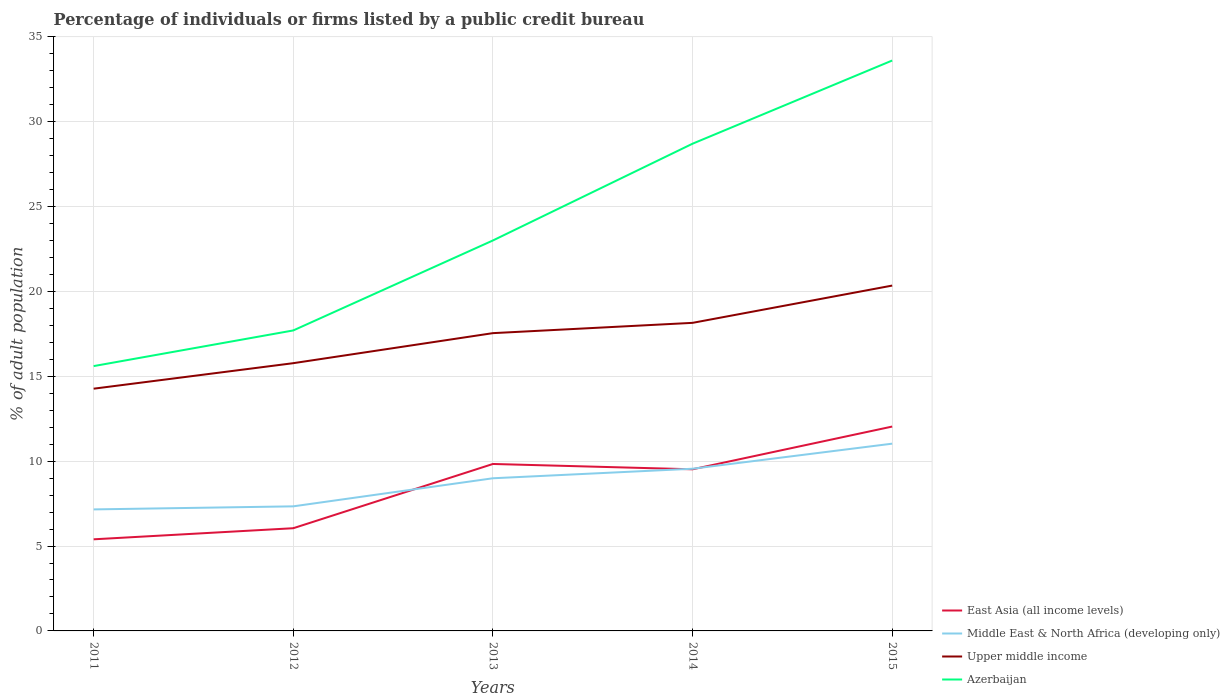Across all years, what is the maximum percentage of population listed by a public credit bureau in Middle East & North Africa (developing only)?
Ensure brevity in your answer.  7.16. What is the total percentage of population listed by a public credit bureau in Azerbaijan in the graph?
Provide a succinct answer. -4.9. What is the difference between the highest and the second highest percentage of population listed by a public credit bureau in Upper middle income?
Make the answer very short. 6.07. Is the percentage of population listed by a public credit bureau in Azerbaijan strictly greater than the percentage of population listed by a public credit bureau in Upper middle income over the years?
Your answer should be very brief. No. How many years are there in the graph?
Ensure brevity in your answer.  5. Are the values on the major ticks of Y-axis written in scientific E-notation?
Your answer should be very brief. No. Does the graph contain any zero values?
Give a very brief answer. No. Does the graph contain grids?
Your answer should be very brief. Yes. Where does the legend appear in the graph?
Offer a very short reply. Bottom right. What is the title of the graph?
Offer a terse response. Percentage of individuals or firms listed by a public credit bureau. What is the label or title of the X-axis?
Keep it short and to the point. Years. What is the label or title of the Y-axis?
Your answer should be very brief. % of adult population. What is the % of adult population in East Asia (all income levels) in 2011?
Ensure brevity in your answer.  5.4. What is the % of adult population of Middle East & North Africa (developing only) in 2011?
Offer a very short reply. 7.16. What is the % of adult population in Upper middle income in 2011?
Keep it short and to the point. 14.27. What is the % of adult population of Azerbaijan in 2011?
Offer a very short reply. 15.6. What is the % of adult population of East Asia (all income levels) in 2012?
Your answer should be very brief. 6.05. What is the % of adult population of Middle East & North Africa (developing only) in 2012?
Provide a succinct answer. 7.34. What is the % of adult population of Upper middle income in 2012?
Your response must be concise. 15.77. What is the % of adult population of Azerbaijan in 2012?
Your answer should be compact. 17.7. What is the % of adult population in East Asia (all income levels) in 2013?
Provide a succinct answer. 9.83. What is the % of adult population in Middle East & North Africa (developing only) in 2013?
Provide a short and direct response. 8.99. What is the % of adult population of Upper middle income in 2013?
Ensure brevity in your answer.  17.54. What is the % of adult population in East Asia (all income levels) in 2014?
Ensure brevity in your answer.  9.52. What is the % of adult population in Middle East & North Africa (developing only) in 2014?
Keep it short and to the point. 9.55. What is the % of adult population in Upper middle income in 2014?
Provide a short and direct response. 18.15. What is the % of adult population in Azerbaijan in 2014?
Provide a short and direct response. 28.7. What is the % of adult population of East Asia (all income levels) in 2015?
Offer a terse response. 12.04. What is the % of adult population of Middle East & North Africa (developing only) in 2015?
Provide a short and direct response. 11.03. What is the % of adult population of Upper middle income in 2015?
Your answer should be compact. 20.34. What is the % of adult population of Azerbaijan in 2015?
Provide a succinct answer. 33.6. Across all years, what is the maximum % of adult population of East Asia (all income levels)?
Give a very brief answer. 12.04. Across all years, what is the maximum % of adult population in Middle East & North Africa (developing only)?
Offer a very short reply. 11.03. Across all years, what is the maximum % of adult population in Upper middle income?
Keep it short and to the point. 20.34. Across all years, what is the maximum % of adult population of Azerbaijan?
Your answer should be very brief. 33.6. Across all years, what is the minimum % of adult population in East Asia (all income levels)?
Provide a short and direct response. 5.4. Across all years, what is the minimum % of adult population of Middle East & North Africa (developing only)?
Ensure brevity in your answer.  7.16. Across all years, what is the minimum % of adult population in Upper middle income?
Your response must be concise. 14.27. What is the total % of adult population of East Asia (all income levels) in the graph?
Your response must be concise. 42.84. What is the total % of adult population of Middle East & North Africa (developing only) in the graph?
Your response must be concise. 44.07. What is the total % of adult population in Upper middle income in the graph?
Your response must be concise. 86.07. What is the total % of adult population in Azerbaijan in the graph?
Your answer should be very brief. 118.6. What is the difference between the % of adult population of East Asia (all income levels) in 2011 and that in 2012?
Your answer should be compact. -0.65. What is the difference between the % of adult population of Middle East & North Africa (developing only) in 2011 and that in 2012?
Offer a very short reply. -0.18. What is the difference between the % of adult population in Upper middle income in 2011 and that in 2012?
Keep it short and to the point. -1.5. What is the difference between the % of adult population of East Asia (all income levels) in 2011 and that in 2013?
Make the answer very short. -4.44. What is the difference between the % of adult population in Middle East & North Africa (developing only) in 2011 and that in 2013?
Your answer should be compact. -1.83. What is the difference between the % of adult population in Upper middle income in 2011 and that in 2013?
Make the answer very short. -3.27. What is the difference between the % of adult population of Azerbaijan in 2011 and that in 2013?
Keep it short and to the point. -7.4. What is the difference between the % of adult population of East Asia (all income levels) in 2011 and that in 2014?
Provide a short and direct response. -4.12. What is the difference between the % of adult population in Middle East & North Africa (developing only) in 2011 and that in 2014?
Offer a very short reply. -2.4. What is the difference between the % of adult population in Upper middle income in 2011 and that in 2014?
Ensure brevity in your answer.  -3.88. What is the difference between the % of adult population in East Asia (all income levels) in 2011 and that in 2015?
Give a very brief answer. -6.64. What is the difference between the % of adult population of Middle East & North Africa (developing only) in 2011 and that in 2015?
Make the answer very short. -3.87. What is the difference between the % of adult population in Upper middle income in 2011 and that in 2015?
Give a very brief answer. -6.07. What is the difference between the % of adult population in East Asia (all income levels) in 2012 and that in 2013?
Provide a succinct answer. -3.78. What is the difference between the % of adult population of Middle East & North Africa (developing only) in 2012 and that in 2013?
Offer a terse response. -1.65. What is the difference between the % of adult population in Upper middle income in 2012 and that in 2013?
Provide a short and direct response. -1.77. What is the difference between the % of adult population in Azerbaijan in 2012 and that in 2013?
Provide a short and direct response. -5.3. What is the difference between the % of adult population in East Asia (all income levels) in 2012 and that in 2014?
Keep it short and to the point. -3.47. What is the difference between the % of adult population of Middle East & North Africa (developing only) in 2012 and that in 2014?
Offer a very short reply. -2.22. What is the difference between the % of adult population in Upper middle income in 2012 and that in 2014?
Keep it short and to the point. -2.38. What is the difference between the % of adult population of East Asia (all income levels) in 2012 and that in 2015?
Make the answer very short. -5.99. What is the difference between the % of adult population of Middle East & North Africa (developing only) in 2012 and that in 2015?
Offer a terse response. -3.69. What is the difference between the % of adult population in Upper middle income in 2012 and that in 2015?
Your answer should be compact. -4.57. What is the difference between the % of adult population of Azerbaijan in 2012 and that in 2015?
Offer a terse response. -15.9. What is the difference between the % of adult population of East Asia (all income levels) in 2013 and that in 2014?
Your answer should be very brief. 0.31. What is the difference between the % of adult population in Middle East & North Africa (developing only) in 2013 and that in 2014?
Your answer should be very brief. -0.56. What is the difference between the % of adult population of Upper middle income in 2013 and that in 2014?
Make the answer very short. -0.61. What is the difference between the % of adult population in Azerbaijan in 2013 and that in 2014?
Your answer should be compact. -5.7. What is the difference between the % of adult population of East Asia (all income levels) in 2013 and that in 2015?
Your answer should be very brief. -2.2. What is the difference between the % of adult population in Middle East & North Africa (developing only) in 2013 and that in 2015?
Offer a terse response. -2.04. What is the difference between the % of adult population in Upper middle income in 2013 and that in 2015?
Offer a very short reply. -2.8. What is the difference between the % of adult population of Azerbaijan in 2013 and that in 2015?
Keep it short and to the point. -10.6. What is the difference between the % of adult population of East Asia (all income levels) in 2014 and that in 2015?
Your answer should be compact. -2.52. What is the difference between the % of adult population of Middle East & North Africa (developing only) in 2014 and that in 2015?
Give a very brief answer. -1.48. What is the difference between the % of adult population in Upper middle income in 2014 and that in 2015?
Give a very brief answer. -2.2. What is the difference between the % of adult population in Azerbaijan in 2014 and that in 2015?
Provide a succinct answer. -4.9. What is the difference between the % of adult population of East Asia (all income levels) in 2011 and the % of adult population of Middle East & North Africa (developing only) in 2012?
Provide a succinct answer. -1.94. What is the difference between the % of adult population of East Asia (all income levels) in 2011 and the % of adult population of Upper middle income in 2012?
Provide a succinct answer. -10.38. What is the difference between the % of adult population of East Asia (all income levels) in 2011 and the % of adult population of Azerbaijan in 2012?
Ensure brevity in your answer.  -12.3. What is the difference between the % of adult population in Middle East & North Africa (developing only) in 2011 and the % of adult population in Upper middle income in 2012?
Your response must be concise. -8.61. What is the difference between the % of adult population in Middle East & North Africa (developing only) in 2011 and the % of adult population in Azerbaijan in 2012?
Make the answer very short. -10.54. What is the difference between the % of adult population in Upper middle income in 2011 and the % of adult population in Azerbaijan in 2012?
Offer a terse response. -3.43. What is the difference between the % of adult population in East Asia (all income levels) in 2011 and the % of adult population in Middle East & North Africa (developing only) in 2013?
Your answer should be compact. -3.6. What is the difference between the % of adult population in East Asia (all income levels) in 2011 and the % of adult population in Upper middle income in 2013?
Ensure brevity in your answer.  -12.14. What is the difference between the % of adult population in East Asia (all income levels) in 2011 and the % of adult population in Azerbaijan in 2013?
Your answer should be compact. -17.6. What is the difference between the % of adult population in Middle East & North Africa (developing only) in 2011 and the % of adult population in Upper middle income in 2013?
Keep it short and to the point. -10.38. What is the difference between the % of adult population of Middle East & North Africa (developing only) in 2011 and the % of adult population of Azerbaijan in 2013?
Provide a succinct answer. -15.84. What is the difference between the % of adult population in Upper middle income in 2011 and the % of adult population in Azerbaijan in 2013?
Keep it short and to the point. -8.73. What is the difference between the % of adult population of East Asia (all income levels) in 2011 and the % of adult population of Middle East & North Africa (developing only) in 2014?
Your answer should be compact. -4.16. What is the difference between the % of adult population in East Asia (all income levels) in 2011 and the % of adult population in Upper middle income in 2014?
Your answer should be very brief. -12.75. What is the difference between the % of adult population of East Asia (all income levels) in 2011 and the % of adult population of Azerbaijan in 2014?
Provide a short and direct response. -23.3. What is the difference between the % of adult population of Middle East & North Africa (developing only) in 2011 and the % of adult population of Upper middle income in 2014?
Provide a short and direct response. -10.99. What is the difference between the % of adult population of Middle East & North Africa (developing only) in 2011 and the % of adult population of Azerbaijan in 2014?
Provide a succinct answer. -21.54. What is the difference between the % of adult population in Upper middle income in 2011 and the % of adult population in Azerbaijan in 2014?
Ensure brevity in your answer.  -14.43. What is the difference between the % of adult population in East Asia (all income levels) in 2011 and the % of adult population in Middle East & North Africa (developing only) in 2015?
Make the answer very short. -5.63. What is the difference between the % of adult population of East Asia (all income levels) in 2011 and the % of adult population of Upper middle income in 2015?
Keep it short and to the point. -14.95. What is the difference between the % of adult population of East Asia (all income levels) in 2011 and the % of adult population of Azerbaijan in 2015?
Your answer should be very brief. -28.2. What is the difference between the % of adult population of Middle East & North Africa (developing only) in 2011 and the % of adult population of Upper middle income in 2015?
Your response must be concise. -13.18. What is the difference between the % of adult population in Middle East & North Africa (developing only) in 2011 and the % of adult population in Azerbaijan in 2015?
Your answer should be very brief. -26.44. What is the difference between the % of adult population of Upper middle income in 2011 and the % of adult population of Azerbaijan in 2015?
Your answer should be very brief. -19.33. What is the difference between the % of adult population in East Asia (all income levels) in 2012 and the % of adult population in Middle East & North Africa (developing only) in 2013?
Your answer should be very brief. -2.94. What is the difference between the % of adult population in East Asia (all income levels) in 2012 and the % of adult population in Upper middle income in 2013?
Your answer should be very brief. -11.49. What is the difference between the % of adult population of East Asia (all income levels) in 2012 and the % of adult population of Azerbaijan in 2013?
Offer a very short reply. -16.95. What is the difference between the % of adult population of Middle East & North Africa (developing only) in 2012 and the % of adult population of Upper middle income in 2013?
Keep it short and to the point. -10.2. What is the difference between the % of adult population in Middle East & North Africa (developing only) in 2012 and the % of adult population in Azerbaijan in 2013?
Keep it short and to the point. -15.66. What is the difference between the % of adult population in Upper middle income in 2012 and the % of adult population in Azerbaijan in 2013?
Ensure brevity in your answer.  -7.23. What is the difference between the % of adult population of East Asia (all income levels) in 2012 and the % of adult population of Middle East & North Africa (developing only) in 2014?
Provide a short and direct response. -3.5. What is the difference between the % of adult population in East Asia (all income levels) in 2012 and the % of adult population in Upper middle income in 2014?
Offer a terse response. -12.1. What is the difference between the % of adult population of East Asia (all income levels) in 2012 and the % of adult population of Azerbaijan in 2014?
Keep it short and to the point. -22.65. What is the difference between the % of adult population of Middle East & North Africa (developing only) in 2012 and the % of adult population of Upper middle income in 2014?
Your answer should be compact. -10.81. What is the difference between the % of adult population in Middle East & North Africa (developing only) in 2012 and the % of adult population in Azerbaijan in 2014?
Provide a succinct answer. -21.36. What is the difference between the % of adult population in Upper middle income in 2012 and the % of adult population in Azerbaijan in 2014?
Provide a short and direct response. -12.93. What is the difference between the % of adult population of East Asia (all income levels) in 2012 and the % of adult population of Middle East & North Africa (developing only) in 2015?
Give a very brief answer. -4.98. What is the difference between the % of adult population in East Asia (all income levels) in 2012 and the % of adult population in Upper middle income in 2015?
Keep it short and to the point. -14.29. What is the difference between the % of adult population in East Asia (all income levels) in 2012 and the % of adult population in Azerbaijan in 2015?
Offer a very short reply. -27.55. What is the difference between the % of adult population in Middle East & North Africa (developing only) in 2012 and the % of adult population in Upper middle income in 2015?
Offer a terse response. -13. What is the difference between the % of adult population of Middle East & North Africa (developing only) in 2012 and the % of adult population of Azerbaijan in 2015?
Keep it short and to the point. -26.26. What is the difference between the % of adult population in Upper middle income in 2012 and the % of adult population in Azerbaijan in 2015?
Make the answer very short. -17.83. What is the difference between the % of adult population of East Asia (all income levels) in 2013 and the % of adult population of Middle East & North Africa (developing only) in 2014?
Your answer should be very brief. 0.28. What is the difference between the % of adult population of East Asia (all income levels) in 2013 and the % of adult population of Upper middle income in 2014?
Ensure brevity in your answer.  -8.31. What is the difference between the % of adult population in East Asia (all income levels) in 2013 and the % of adult population in Azerbaijan in 2014?
Provide a short and direct response. -18.87. What is the difference between the % of adult population in Middle East & North Africa (developing only) in 2013 and the % of adult population in Upper middle income in 2014?
Your response must be concise. -9.15. What is the difference between the % of adult population of Middle East & North Africa (developing only) in 2013 and the % of adult population of Azerbaijan in 2014?
Make the answer very short. -19.71. What is the difference between the % of adult population in Upper middle income in 2013 and the % of adult population in Azerbaijan in 2014?
Ensure brevity in your answer.  -11.16. What is the difference between the % of adult population of East Asia (all income levels) in 2013 and the % of adult population of Middle East & North Africa (developing only) in 2015?
Your response must be concise. -1.2. What is the difference between the % of adult population in East Asia (all income levels) in 2013 and the % of adult population in Upper middle income in 2015?
Ensure brevity in your answer.  -10.51. What is the difference between the % of adult population of East Asia (all income levels) in 2013 and the % of adult population of Azerbaijan in 2015?
Offer a very short reply. -23.77. What is the difference between the % of adult population in Middle East & North Africa (developing only) in 2013 and the % of adult population in Upper middle income in 2015?
Your answer should be very brief. -11.35. What is the difference between the % of adult population in Middle East & North Africa (developing only) in 2013 and the % of adult population in Azerbaijan in 2015?
Give a very brief answer. -24.61. What is the difference between the % of adult population of Upper middle income in 2013 and the % of adult population of Azerbaijan in 2015?
Your answer should be very brief. -16.06. What is the difference between the % of adult population of East Asia (all income levels) in 2014 and the % of adult population of Middle East & North Africa (developing only) in 2015?
Offer a very short reply. -1.51. What is the difference between the % of adult population of East Asia (all income levels) in 2014 and the % of adult population of Upper middle income in 2015?
Ensure brevity in your answer.  -10.82. What is the difference between the % of adult population of East Asia (all income levels) in 2014 and the % of adult population of Azerbaijan in 2015?
Offer a terse response. -24.08. What is the difference between the % of adult population in Middle East & North Africa (developing only) in 2014 and the % of adult population in Upper middle income in 2015?
Your answer should be compact. -10.79. What is the difference between the % of adult population in Middle East & North Africa (developing only) in 2014 and the % of adult population in Azerbaijan in 2015?
Offer a very short reply. -24.05. What is the difference between the % of adult population in Upper middle income in 2014 and the % of adult population in Azerbaijan in 2015?
Your answer should be very brief. -15.45. What is the average % of adult population in East Asia (all income levels) per year?
Your answer should be compact. 8.57. What is the average % of adult population of Middle East & North Africa (developing only) per year?
Offer a terse response. 8.81. What is the average % of adult population in Upper middle income per year?
Give a very brief answer. 17.21. What is the average % of adult population of Azerbaijan per year?
Keep it short and to the point. 23.72. In the year 2011, what is the difference between the % of adult population in East Asia (all income levels) and % of adult population in Middle East & North Africa (developing only)?
Give a very brief answer. -1.76. In the year 2011, what is the difference between the % of adult population in East Asia (all income levels) and % of adult population in Upper middle income?
Your answer should be very brief. -8.87. In the year 2011, what is the difference between the % of adult population in East Asia (all income levels) and % of adult population in Azerbaijan?
Your answer should be very brief. -10.2. In the year 2011, what is the difference between the % of adult population of Middle East & North Africa (developing only) and % of adult population of Upper middle income?
Make the answer very short. -7.11. In the year 2011, what is the difference between the % of adult population in Middle East & North Africa (developing only) and % of adult population in Azerbaijan?
Provide a succinct answer. -8.44. In the year 2011, what is the difference between the % of adult population in Upper middle income and % of adult population in Azerbaijan?
Offer a terse response. -1.33. In the year 2012, what is the difference between the % of adult population in East Asia (all income levels) and % of adult population in Middle East & North Africa (developing only)?
Make the answer very short. -1.29. In the year 2012, what is the difference between the % of adult population in East Asia (all income levels) and % of adult population in Upper middle income?
Your answer should be compact. -9.72. In the year 2012, what is the difference between the % of adult population of East Asia (all income levels) and % of adult population of Azerbaijan?
Your response must be concise. -11.65. In the year 2012, what is the difference between the % of adult population in Middle East & North Africa (developing only) and % of adult population in Upper middle income?
Make the answer very short. -8.43. In the year 2012, what is the difference between the % of adult population of Middle East & North Africa (developing only) and % of adult population of Azerbaijan?
Provide a succinct answer. -10.36. In the year 2012, what is the difference between the % of adult population in Upper middle income and % of adult population in Azerbaijan?
Provide a short and direct response. -1.93. In the year 2013, what is the difference between the % of adult population in East Asia (all income levels) and % of adult population in Middle East & North Africa (developing only)?
Offer a very short reply. 0.84. In the year 2013, what is the difference between the % of adult population in East Asia (all income levels) and % of adult population in Upper middle income?
Ensure brevity in your answer.  -7.71. In the year 2013, what is the difference between the % of adult population of East Asia (all income levels) and % of adult population of Azerbaijan?
Your response must be concise. -13.17. In the year 2013, what is the difference between the % of adult population in Middle East & North Africa (developing only) and % of adult population in Upper middle income?
Provide a succinct answer. -8.55. In the year 2013, what is the difference between the % of adult population in Middle East & North Africa (developing only) and % of adult population in Azerbaijan?
Offer a terse response. -14.01. In the year 2013, what is the difference between the % of adult population of Upper middle income and % of adult population of Azerbaijan?
Your answer should be very brief. -5.46. In the year 2014, what is the difference between the % of adult population of East Asia (all income levels) and % of adult population of Middle East & North Africa (developing only)?
Your response must be concise. -0.03. In the year 2014, what is the difference between the % of adult population of East Asia (all income levels) and % of adult population of Upper middle income?
Give a very brief answer. -8.63. In the year 2014, what is the difference between the % of adult population of East Asia (all income levels) and % of adult population of Azerbaijan?
Keep it short and to the point. -19.18. In the year 2014, what is the difference between the % of adult population of Middle East & North Africa (developing only) and % of adult population of Upper middle income?
Offer a very short reply. -8.59. In the year 2014, what is the difference between the % of adult population in Middle East & North Africa (developing only) and % of adult population in Azerbaijan?
Provide a short and direct response. -19.15. In the year 2014, what is the difference between the % of adult population in Upper middle income and % of adult population in Azerbaijan?
Offer a terse response. -10.55. In the year 2015, what is the difference between the % of adult population of East Asia (all income levels) and % of adult population of Middle East & North Africa (developing only)?
Ensure brevity in your answer.  1.01. In the year 2015, what is the difference between the % of adult population in East Asia (all income levels) and % of adult population in Upper middle income?
Give a very brief answer. -8.3. In the year 2015, what is the difference between the % of adult population of East Asia (all income levels) and % of adult population of Azerbaijan?
Your answer should be very brief. -21.56. In the year 2015, what is the difference between the % of adult population in Middle East & North Africa (developing only) and % of adult population in Upper middle income?
Offer a very short reply. -9.31. In the year 2015, what is the difference between the % of adult population of Middle East & North Africa (developing only) and % of adult population of Azerbaijan?
Offer a very short reply. -22.57. In the year 2015, what is the difference between the % of adult population of Upper middle income and % of adult population of Azerbaijan?
Ensure brevity in your answer.  -13.26. What is the ratio of the % of adult population in East Asia (all income levels) in 2011 to that in 2012?
Offer a terse response. 0.89. What is the ratio of the % of adult population of Middle East & North Africa (developing only) in 2011 to that in 2012?
Your response must be concise. 0.98. What is the ratio of the % of adult population in Upper middle income in 2011 to that in 2012?
Give a very brief answer. 0.9. What is the ratio of the % of adult population in Azerbaijan in 2011 to that in 2012?
Your answer should be compact. 0.88. What is the ratio of the % of adult population of East Asia (all income levels) in 2011 to that in 2013?
Keep it short and to the point. 0.55. What is the ratio of the % of adult population of Middle East & North Africa (developing only) in 2011 to that in 2013?
Make the answer very short. 0.8. What is the ratio of the % of adult population in Upper middle income in 2011 to that in 2013?
Keep it short and to the point. 0.81. What is the ratio of the % of adult population of Azerbaijan in 2011 to that in 2013?
Provide a short and direct response. 0.68. What is the ratio of the % of adult population of East Asia (all income levels) in 2011 to that in 2014?
Ensure brevity in your answer.  0.57. What is the ratio of the % of adult population in Middle East & North Africa (developing only) in 2011 to that in 2014?
Provide a succinct answer. 0.75. What is the ratio of the % of adult population of Upper middle income in 2011 to that in 2014?
Offer a very short reply. 0.79. What is the ratio of the % of adult population of Azerbaijan in 2011 to that in 2014?
Make the answer very short. 0.54. What is the ratio of the % of adult population of East Asia (all income levels) in 2011 to that in 2015?
Keep it short and to the point. 0.45. What is the ratio of the % of adult population in Middle East & North Africa (developing only) in 2011 to that in 2015?
Provide a succinct answer. 0.65. What is the ratio of the % of adult population of Upper middle income in 2011 to that in 2015?
Your answer should be compact. 0.7. What is the ratio of the % of adult population of Azerbaijan in 2011 to that in 2015?
Offer a very short reply. 0.46. What is the ratio of the % of adult population in East Asia (all income levels) in 2012 to that in 2013?
Keep it short and to the point. 0.62. What is the ratio of the % of adult population in Middle East & North Africa (developing only) in 2012 to that in 2013?
Your response must be concise. 0.82. What is the ratio of the % of adult population of Upper middle income in 2012 to that in 2013?
Your answer should be very brief. 0.9. What is the ratio of the % of adult population in Azerbaijan in 2012 to that in 2013?
Make the answer very short. 0.77. What is the ratio of the % of adult population of East Asia (all income levels) in 2012 to that in 2014?
Offer a terse response. 0.64. What is the ratio of the % of adult population in Middle East & North Africa (developing only) in 2012 to that in 2014?
Your answer should be very brief. 0.77. What is the ratio of the % of adult population of Upper middle income in 2012 to that in 2014?
Keep it short and to the point. 0.87. What is the ratio of the % of adult population of Azerbaijan in 2012 to that in 2014?
Give a very brief answer. 0.62. What is the ratio of the % of adult population of East Asia (all income levels) in 2012 to that in 2015?
Your answer should be very brief. 0.5. What is the ratio of the % of adult population in Middle East & North Africa (developing only) in 2012 to that in 2015?
Your answer should be very brief. 0.67. What is the ratio of the % of adult population in Upper middle income in 2012 to that in 2015?
Offer a terse response. 0.78. What is the ratio of the % of adult population of Azerbaijan in 2012 to that in 2015?
Provide a short and direct response. 0.53. What is the ratio of the % of adult population of East Asia (all income levels) in 2013 to that in 2014?
Provide a succinct answer. 1.03. What is the ratio of the % of adult population of Upper middle income in 2013 to that in 2014?
Your response must be concise. 0.97. What is the ratio of the % of adult population of Azerbaijan in 2013 to that in 2014?
Offer a terse response. 0.8. What is the ratio of the % of adult population of East Asia (all income levels) in 2013 to that in 2015?
Your response must be concise. 0.82. What is the ratio of the % of adult population of Middle East & North Africa (developing only) in 2013 to that in 2015?
Keep it short and to the point. 0.82. What is the ratio of the % of adult population in Upper middle income in 2013 to that in 2015?
Your response must be concise. 0.86. What is the ratio of the % of adult population in Azerbaijan in 2013 to that in 2015?
Provide a succinct answer. 0.68. What is the ratio of the % of adult population of East Asia (all income levels) in 2014 to that in 2015?
Make the answer very short. 0.79. What is the ratio of the % of adult population of Middle East & North Africa (developing only) in 2014 to that in 2015?
Provide a short and direct response. 0.87. What is the ratio of the % of adult population in Upper middle income in 2014 to that in 2015?
Your answer should be very brief. 0.89. What is the ratio of the % of adult population of Azerbaijan in 2014 to that in 2015?
Your answer should be very brief. 0.85. What is the difference between the highest and the second highest % of adult population of East Asia (all income levels)?
Your response must be concise. 2.2. What is the difference between the highest and the second highest % of adult population in Middle East & North Africa (developing only)?
Provide a succinct answer. 1.48. What is the difference between the highest and the second highest % of adult population of Upper middle income?
Offer a very short reply. 2.2. What is the difference between the highest and the lowest % of adult population in East Asia (all income levels)?
Offer a terse response. 6.64. What is the difference between the highest and the lowest % of adult population of Middle East & North Africa (developing only)?
Provide a short and direct response. 3.87. What is the difference between the highest and the lowest % of adult population in Upper middle income?
Provide a short and direct response. 6.07. 